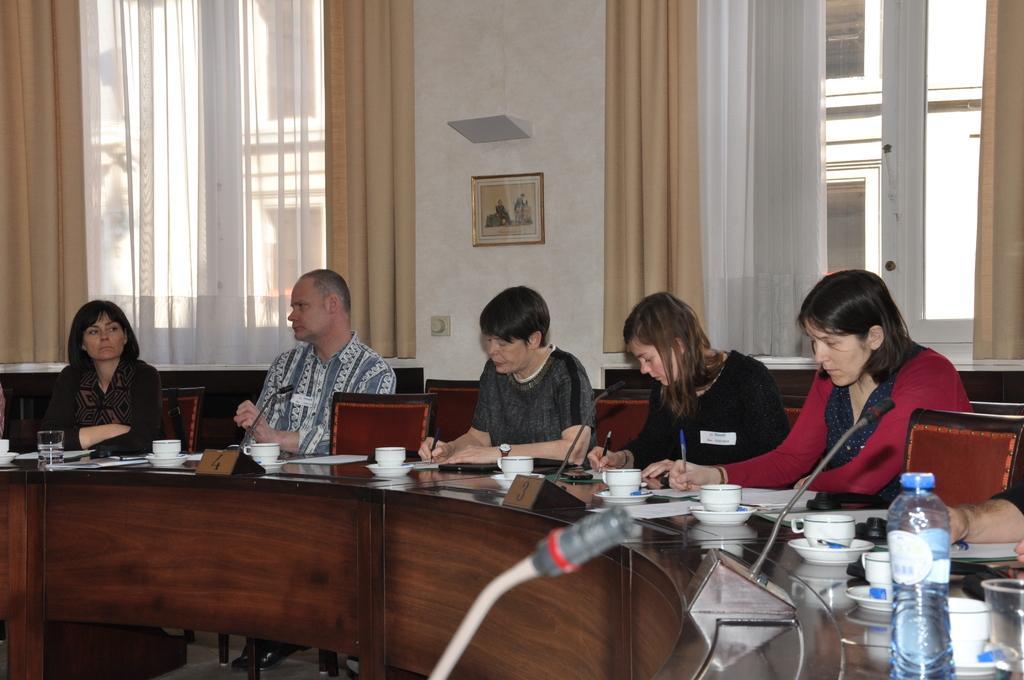Describe this image in one or two sentences. In this picture i could see some five people sitting on the chair near the table and working on some papers. In the background i could see the glass windows and white colored curtain and brown colored curtain and a picture frame hanging on the wall. On the table there are cups, saucers, name plate and mic and water bottles and glasses too. 